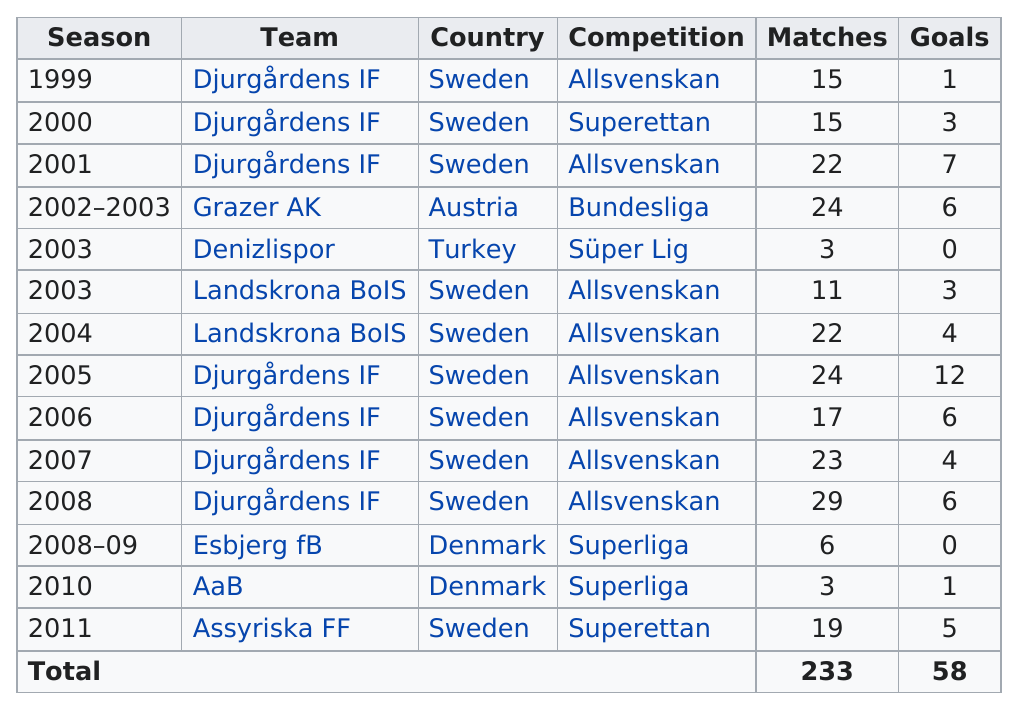Indicate a few pertinent items in this graphic. Jones Kusi-Asare played 15 matches in his first season. The season with the highest number of goals was 2005. The total number of matches is 233. The country in which Team Djurgårdens is not from is Sweden. Djurgårdens IF boasts the most goals, making them a team to watch. 